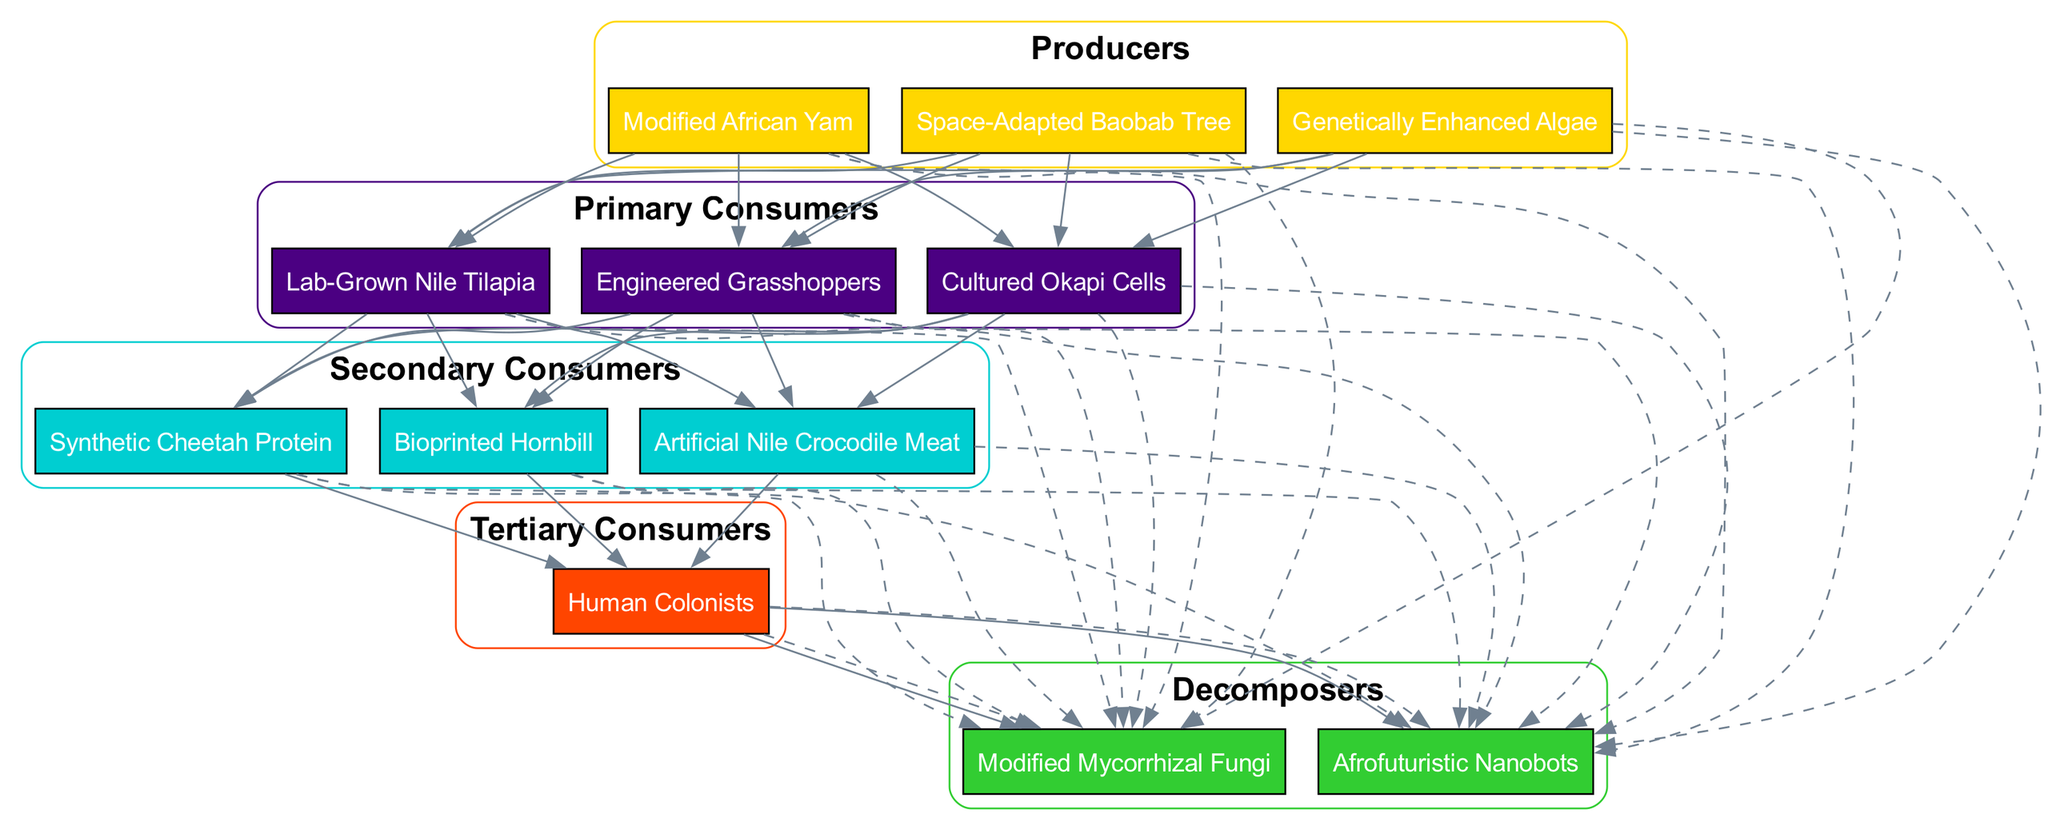What are the producers in the food chain? The producers are the first trophic level and consist of the organisms that produce biomass from sunlight or chemical energy. In the provided data, the producers listed are Modified African Yam, Space-Adapted Baobab Tree, and Genetically Enhanced Algae.
Answer: Modified African Yam, Space-Adapted Baobab Tree, Genetically Enhanced Algae How many primary consumers are there? To find the number of primary consumers, we look at the primary consumers listed in the diagram. There are three organisms: Lab-Grown Nile Tilapia, Engineered Grasshoppers, and Cultured Okapi Cells. Therefore, the total count is three.
Answer: 3 Which organism is at the tertiary consumer level? The tertiary consumers are those that consume secondary consumers. In the data, the only organism mentioned in the tertiary consumer level is Human Colonists.
Answer: Human Colonists What is the relationship between Lab-Grown Nile Tilapia and Modified African Yam? Lab-Grown Nile Tilapia is a primary consumer, while Modified African Yam is a producer. The relationship is that the Lab-Grown Nile Tilapia consumes the Modified African Yam, which means the Nile Tilapia benefits from the energy stored in the Yam.
Answer: Consumer of How many decomposers are connected to the biomass pyramid? Decomposers play a vital role in breaking down dead organic material, and in this dataset, there are two decomposers: Afrofuturistic Nanobots and Modified Mycorrhizal Fungi. Thus, the total count of decomposers connected is two.
Answer: 2 What connects the secondary consumers to the decomposers? The secondary consumers, including Synthetic Cheetah Protein, Bioprinted Hornbill, and Artificial Nile Crocodile Meat, have dashed lines connecting them to the decomposers, indicating that when they die or their biomass decomposes, it becomes part of the nutrient cycle facilitated by the decomposers.
Answer: Dashed lines Which group does Artificial Nile Crocodile Meat belong to? Artificial Nile Crocodile Meat is categorized as a secondary consumer in the biomass pyramid, as it consumes primary consumers for its energy.
Answer: Secondary consumers Which level is the highest in the biomass pyramid? The highest level in the biomass pyramid is the tertiary consumer level, which includes organisms that are at the top of the food chain. Here, the only entity is Human Colonists, indicating they occupy the highest position.
Answer: Tertiary consumers How are the decomposers represented in relation to the other levels? The diagram shows decomposers being connected to all levels of the food chain, indicated by dashed lines. This representation signifies their essential role in recycling nutrients from all trophic levels back into the ecosystem.
Answer: Dashed lines connecting all levels 